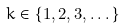Convert formula to latex. <formula><loc_0><loc_0><loc_500><loc_500>k \in \{ 1 , 2 , 3 , \dots \}</formula> 